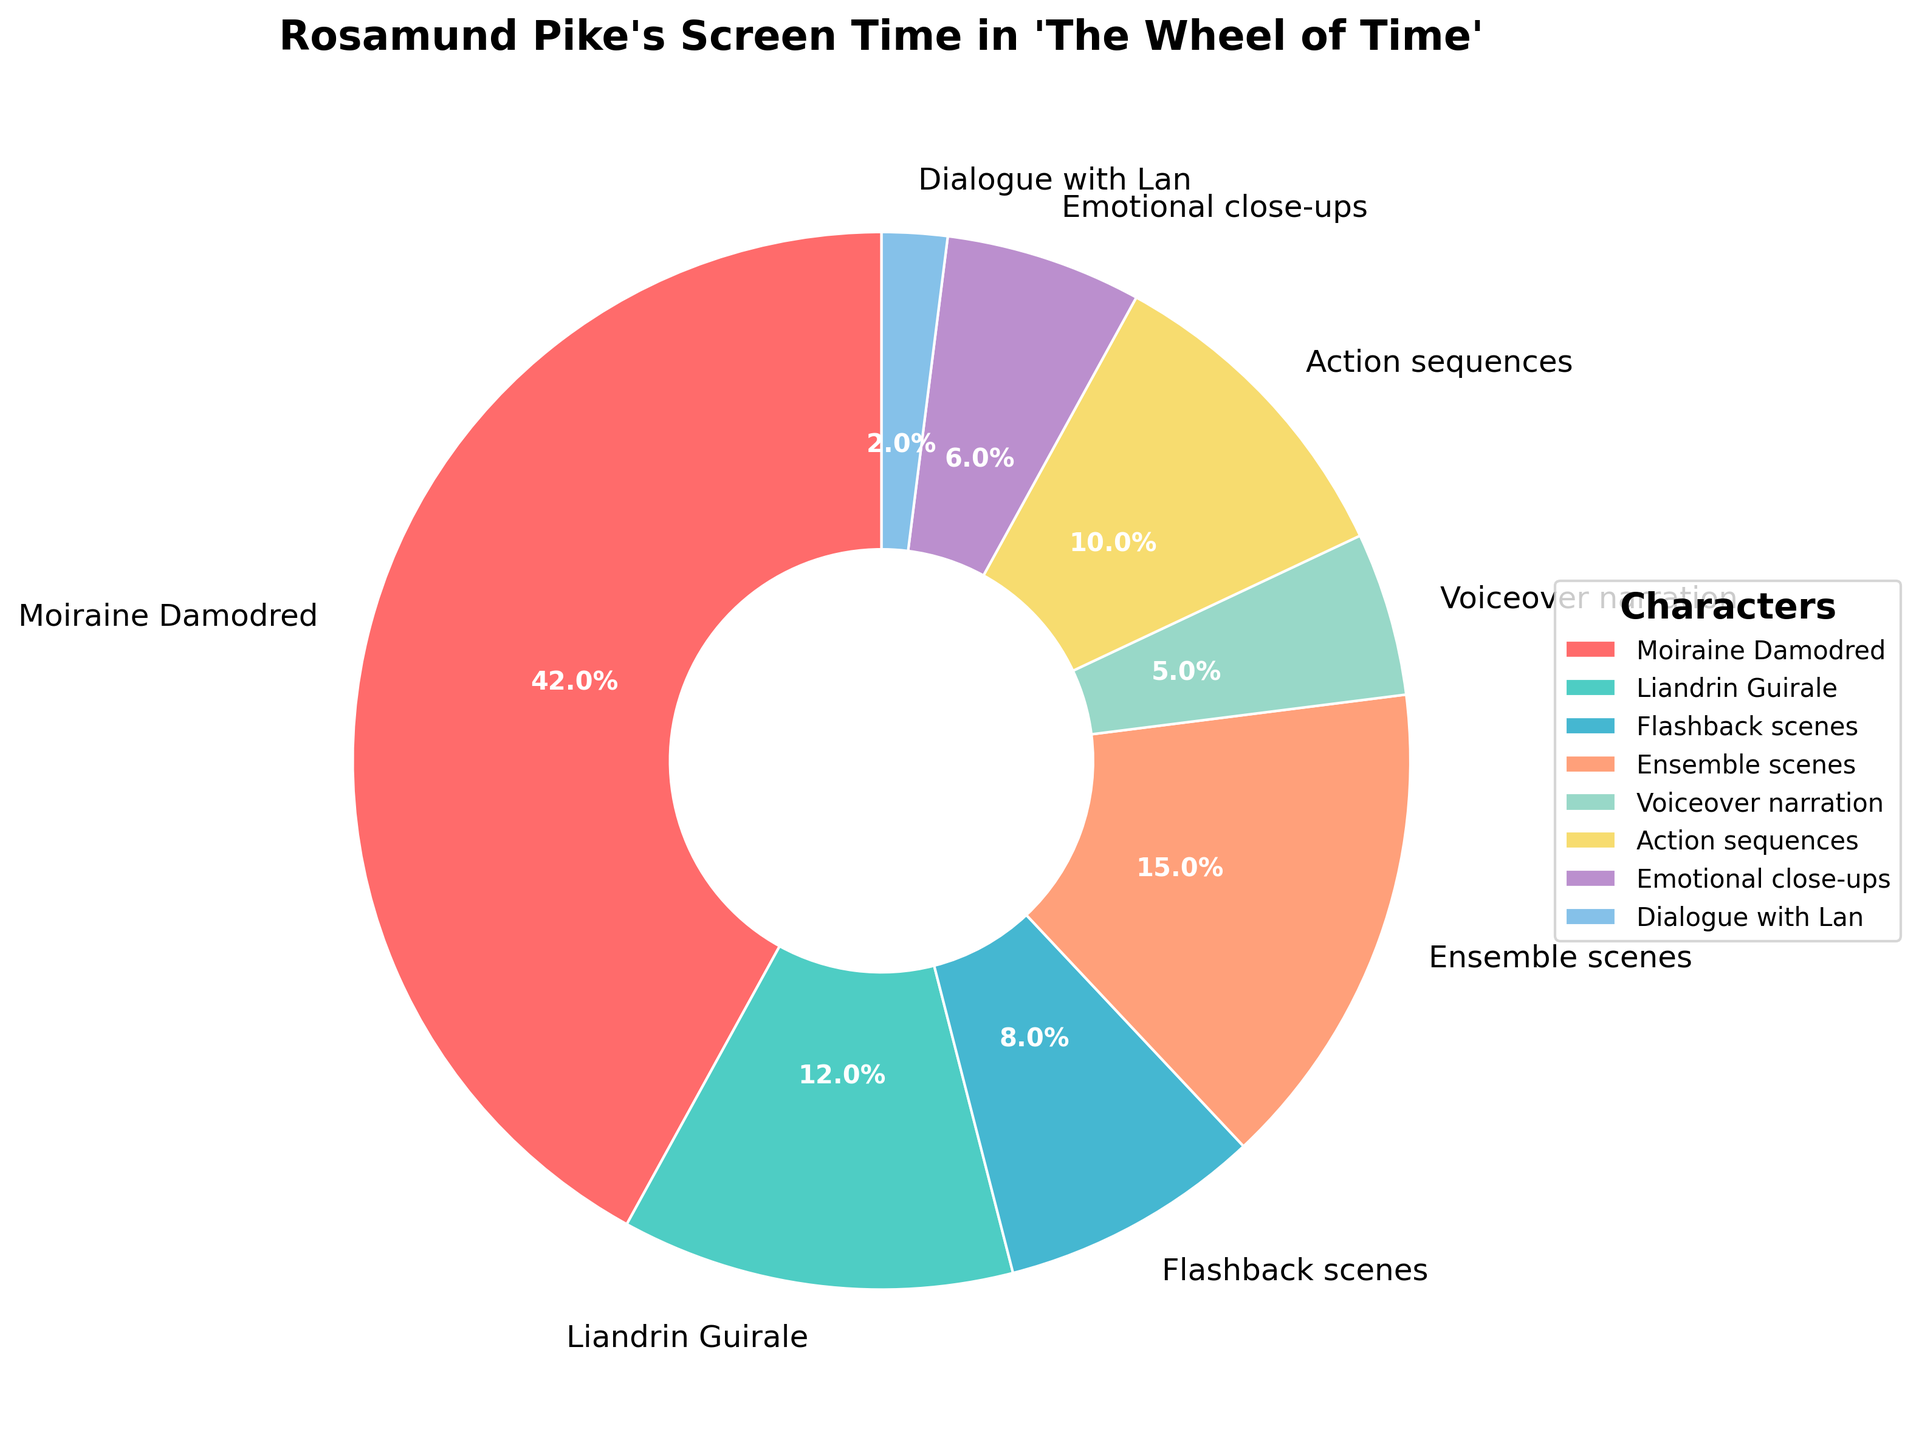What is the category with the highest percentage of screen time for Rosamund Pike in 'The Wheel of Time'? According to the pie chart, the largest wedge represents Rosamund Pike's screen time as the character Moiraine Damodred, which takes up 42% of the pie.
Answer: Moiraine Damodred Which two categories together account for 25% of Rosamund Pike's screen time? From the pie chart, the "Voiceover narration" accounts for 5%, and the "Emotional close-ups" account for 6%. Together these total 11%. However, the "Action sequences" account for 10%. Adding this to "Voiceover narration", we get 15%. Looking for another combination, "Dialogue with Lan" has 2%, and "Flashback scenes" have 8%, combined they total 10%. Therefore "Ensemble scenes" with 15% combined with "Voiceover narration" at 10% makes 25%.
Answer: Ensemble scenes and Action sequences Which category has more screen time: action sequences or emotional close-ups? The chart shows a wedge for "Action sequences" labeled with 10%, and "Emotional close-ups" labeled with 6%. Action sequences have more screen time.
Answer: Action sequences What is the total percentage of screen time spent on scenes where Rosamund Pike appears prominently, i.e., Moiraine Damodred, Emotional close-ups, and Dialogue with Lan combined? By summing the percentages for Moiraine Damodred (42%), Emotional close-ups (6%), and Dialogue with Lan (2%), the total is 42 + 6 + 2 = 50%.
Answer: 50% How much more screen time does Moiraine Damodred have compared to Liandrin Guirale? The pie chart indicates Moiraine Damodred has 42% screen time and Liandrin Guirale has 12%. The difference is 42 - 12 = 30%.
Answer: 30% Which colors represent the categories with less than 10% screen time? The figure uses different colors for each category. The categories with less than 10% screen time are "Flashback scenes" (8%), "Voiceover narration" (5%), "Emotional close-ups" (6%), and "Dialogue with Lan" (2%). The corresponding colors are pink, yellow, purple, and light blue respectively.
Answer: pink, yellow, purple, and light blue Based on visual inspection, which category lies next to Liandrin Guirale in terms of percentage? The pie chart segments are ordered clockwise and labeled. By looking at the segment sizes, the one next to Liandrin Guirale (12%) clockwise is "Flashback scenes", which constitutes 8% of the pie.
Answer: Flashback scenes If we combine the screen times of flashback scenes, voiceover narration, and emotional close-ups, what percentage of total screen time do they represent? Summing up the percentages given for "Flashback scenes" (8%), "Voiceover narration" (5%), and "Emotional close-ups" (6%) results in 8 + 5 + 6 = 19%.
Answer: 19% 